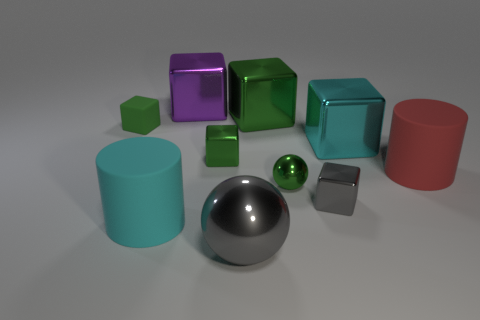What number of cylinders are green shiny things or tiny objects?
Ensure brevity in your answer.  0. What size is the red thing?
Offer a terse response. Large. There is a tiny gray cube; how many metal things are in front of it?
Offer a very short reply. 1. There is a cyan thing on the right side of the cylinder to the left of the red matte cylinder; what size is it?
Offer a very short reply. Large. There is a large cyan thing that is on the right side of the big purple metal object; is it the same shape as the large metal object that is in front of the cyan matte thing?
Offer a very short reply. No. There is a gray object that is behind the gray metallic ball in front of the big purple thing; what shape is it?
Provide a short and direct response. Cube. There is a metal cube that is both behind the large cyan metallic cube and in front of the purple object; what size is it?
Make the answer very short. Large. Do the large red thing and the big cyan object left of the big gray ball have the same shape?
Provide a short and direct response. Yes. There is a cyan metal thing that is the same shape as the tiny matte object; what is its size?
Your answer should be very brief. Large. Do the small rubber block and the tiny metallic object that is behind the large red thing have the same color?
Ensure brevity in your answer.  Yes. 